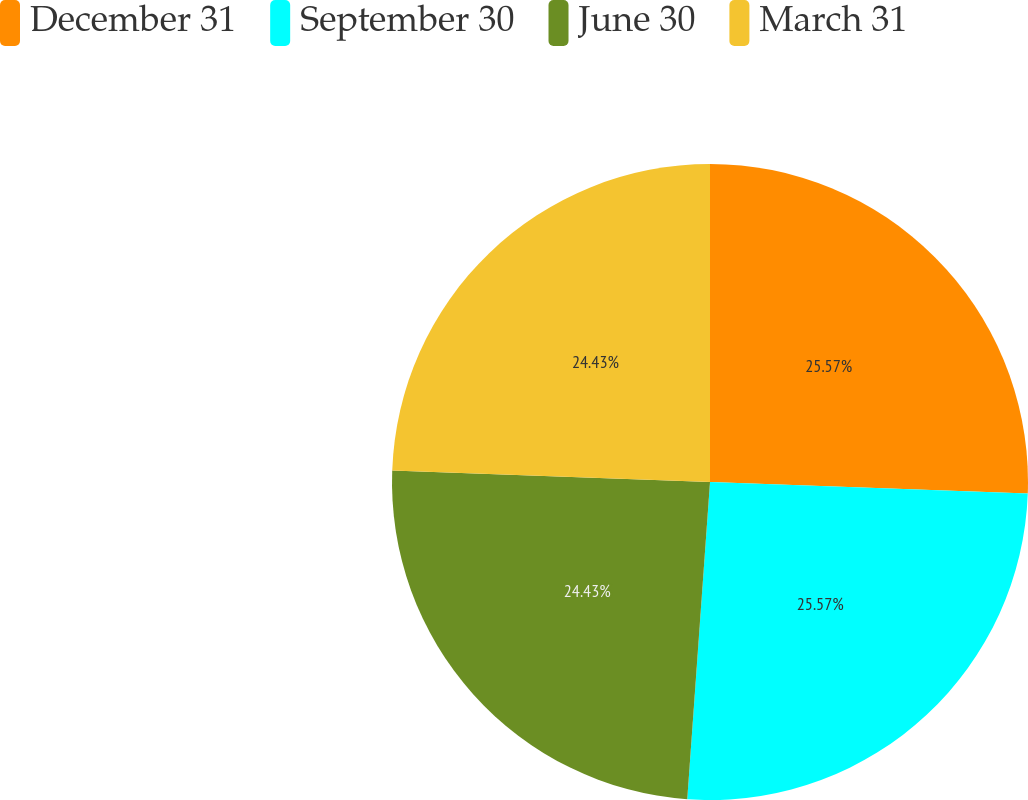<chart> <loc_0><loc_0><loc_500><loc_500><pie_chart><fcel>December 31<fcel>September 30<fcel>June 30<fcel>March 31<nl><fcel>25.57%<fcel>25.57%<fcel>24.43%<fcel>24.43%<nl></chart> 